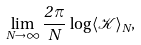<formula> <loc_0><loc_0><loc_500><loc_500>\lim _ { N \to \infty } \frac { 2 \, \pi } { N } \, \log \langle \mathcal { K } \rangle _ { N } ,</formula> 